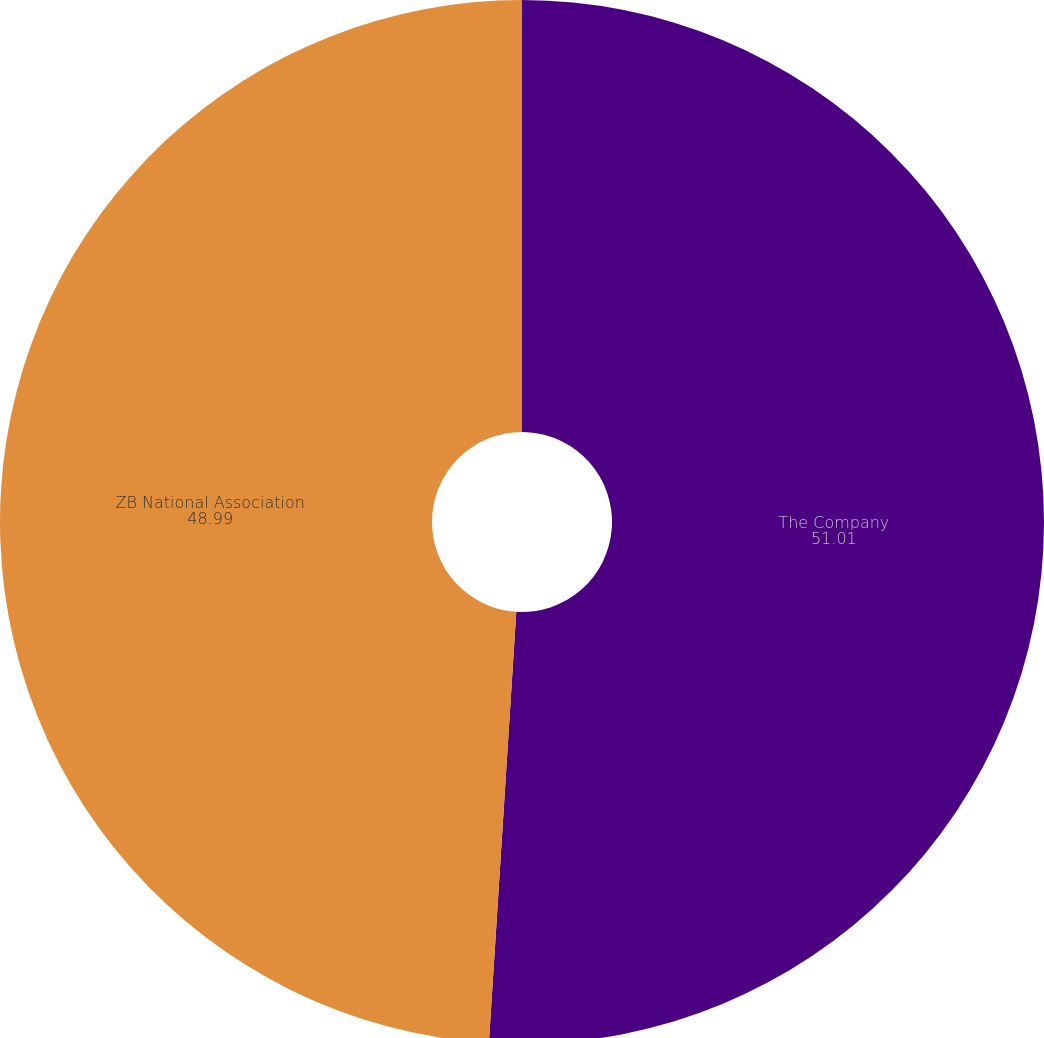<chart> <loc_0><loc_0><loc_500><loc_500><pie_chart><fcel>The Company<fcel>ZB National Association<nl><fcel>51.01%<fcel>48.99%<nl></chart> 